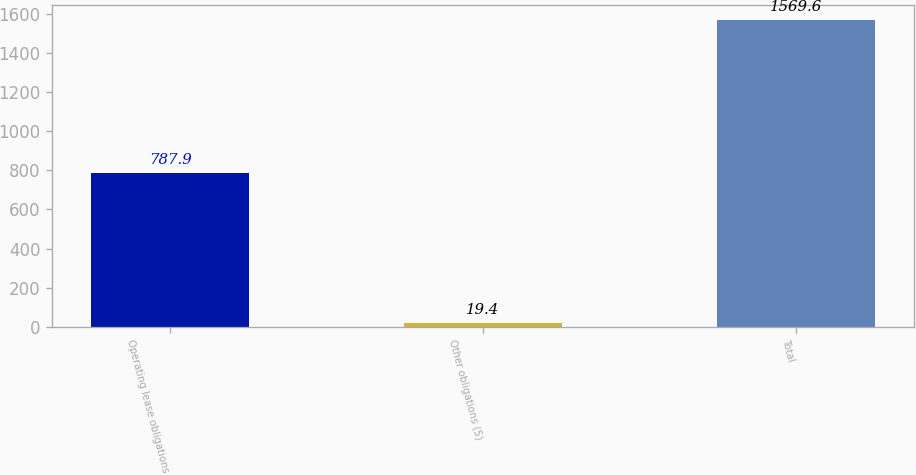Convert chart to OTSL. <chart><loc_0><loc_0><loc_500><loc_500><bar_chart><fcel>Operating lease obligations<fcel>Other obligations (5)<fcel>Total<nl><fcel>787.9<fcel>19.4<fcel>1569.6<nl></chart> 